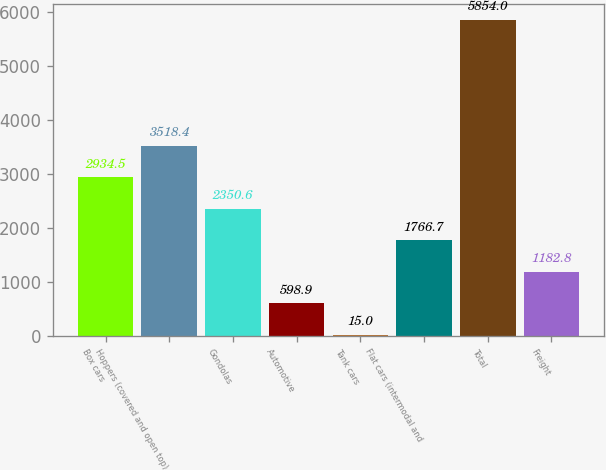Convert chart to OTSL. <chart><loc_0><loc_0><loc_500><loc_500><bar_chart><fcel>Box cars<fcel>Hoppers (covered and open top)<fcel>Gondolas<fcel>Automotive<fcel>Tank cars<fcel>Flat cars (intermodal and<fcel>Total<fcel>Freight<nl><fcel>2934.5<fcel>3518.4<fcel>2350.6<fcel>598.9<fcel>15<fcel>1766.7<fcel>5854<fcel>1182.8<nl></chart> 